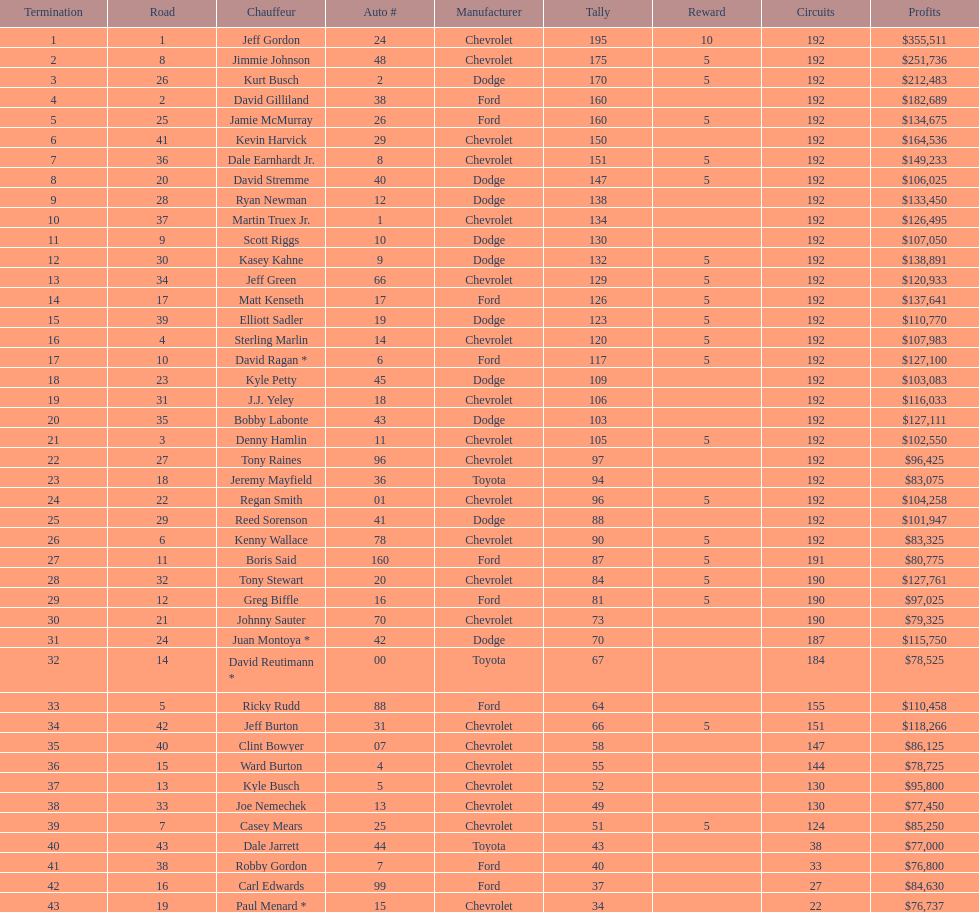For this specific race, what was the number of drivers who didn't get any bonus? 23. 